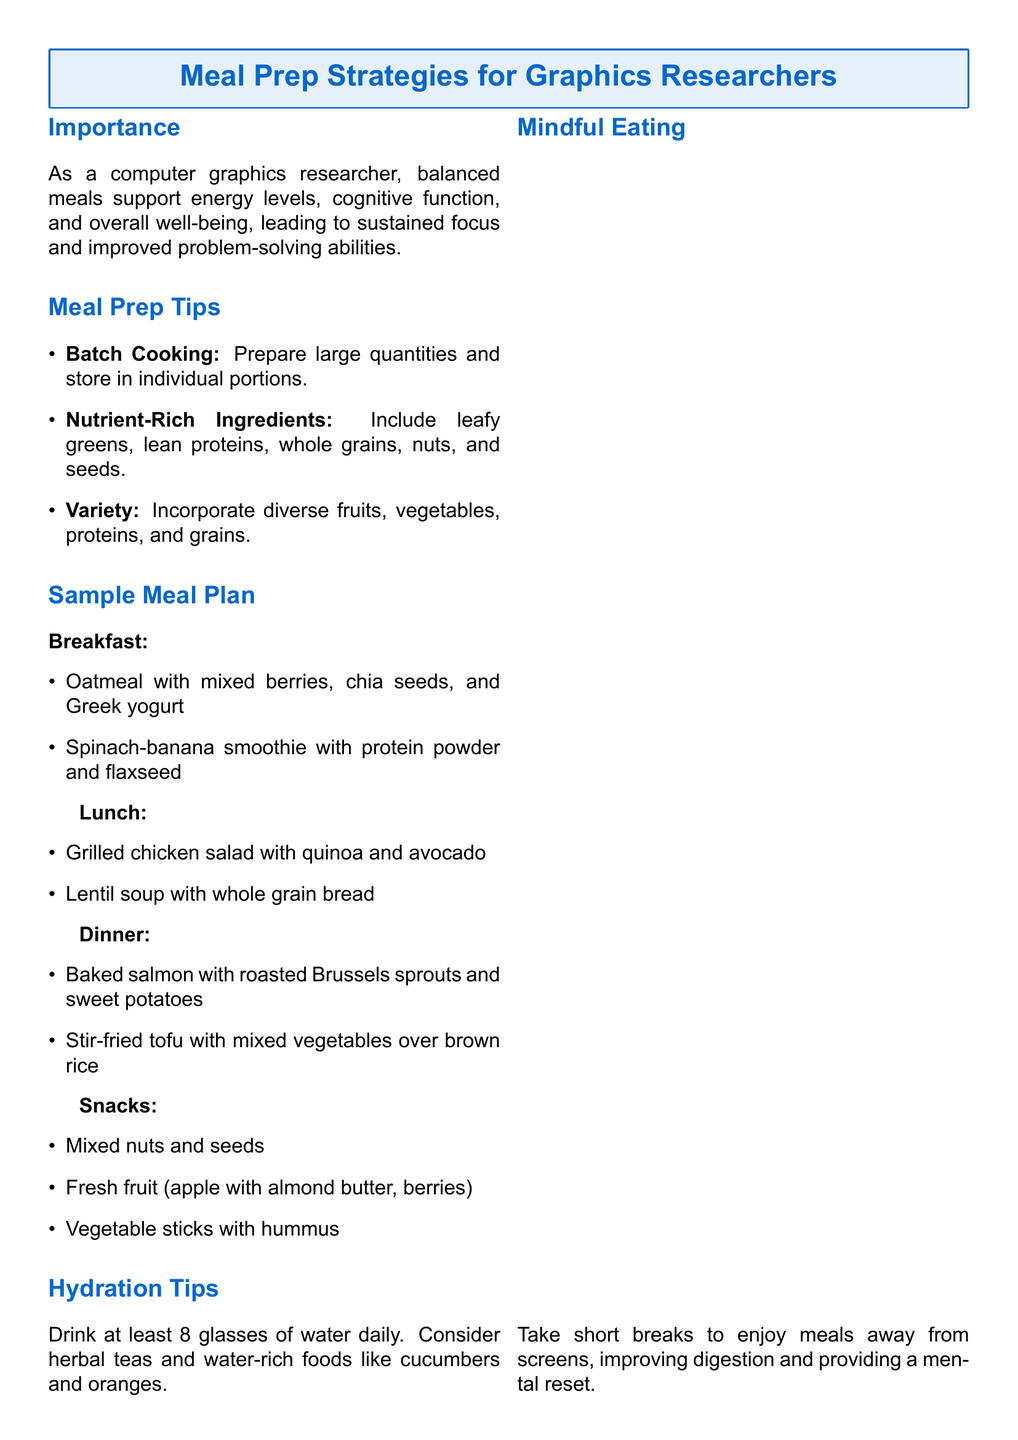What is the main purpose of balanced meals? The purpose of balanced meals is to support energy levels, cognitive function, and overall well-being.
Answer: support energy levels, cognitive function, and overall well-being What type of cooking method is recommended? The document suggests preparing large quantities and storing them in individual portions, which is known as batch cooking.
Answer: Batch Cooking What are two examples of breakfast items? The breakfast items listed are oatmeal with mixed berries and a spinach-banana smoothie.
Answer: oatmeal with mixed berries, spinach-banana smoothie How many glasses of water should be consumed daily? The document recommends drinking at least 8 glasses of water daily.
Answer: 8 glasses What is a suggested dinner option? The document lists baked salmon with roasted Brussels sprouts and sweet potatoes as a dinner option.
Answer: baked salmon with roasted Brussels sprouts and sweet potatoes Why is mindful eating recommended? Mindful eating is encouraged to improve digestion and provide a mental reset by taking breaks from screens.
Answer: improve digestion and provide a mental reset Which nutrient-rich ingredients are suggested? The document highlights including leafy greens, lean proteins, whole grains, nuts, and seeds as nutrient-rich ingredients.
Answer: leafy greens, lean proteins, whole grains, nuts, seeds What type of snacks are recommended? Recommended snacks include mixed nuts and seeds, fresh fruit, and vegetable sticks with hummus.
Answer: mixed nuts and seeds, fresh fruit, vegetable sticks with hummus What should accompany meals away from screens? The document suggests taking short breaks to enjoy meals away from screens.
Answer: short breaks 